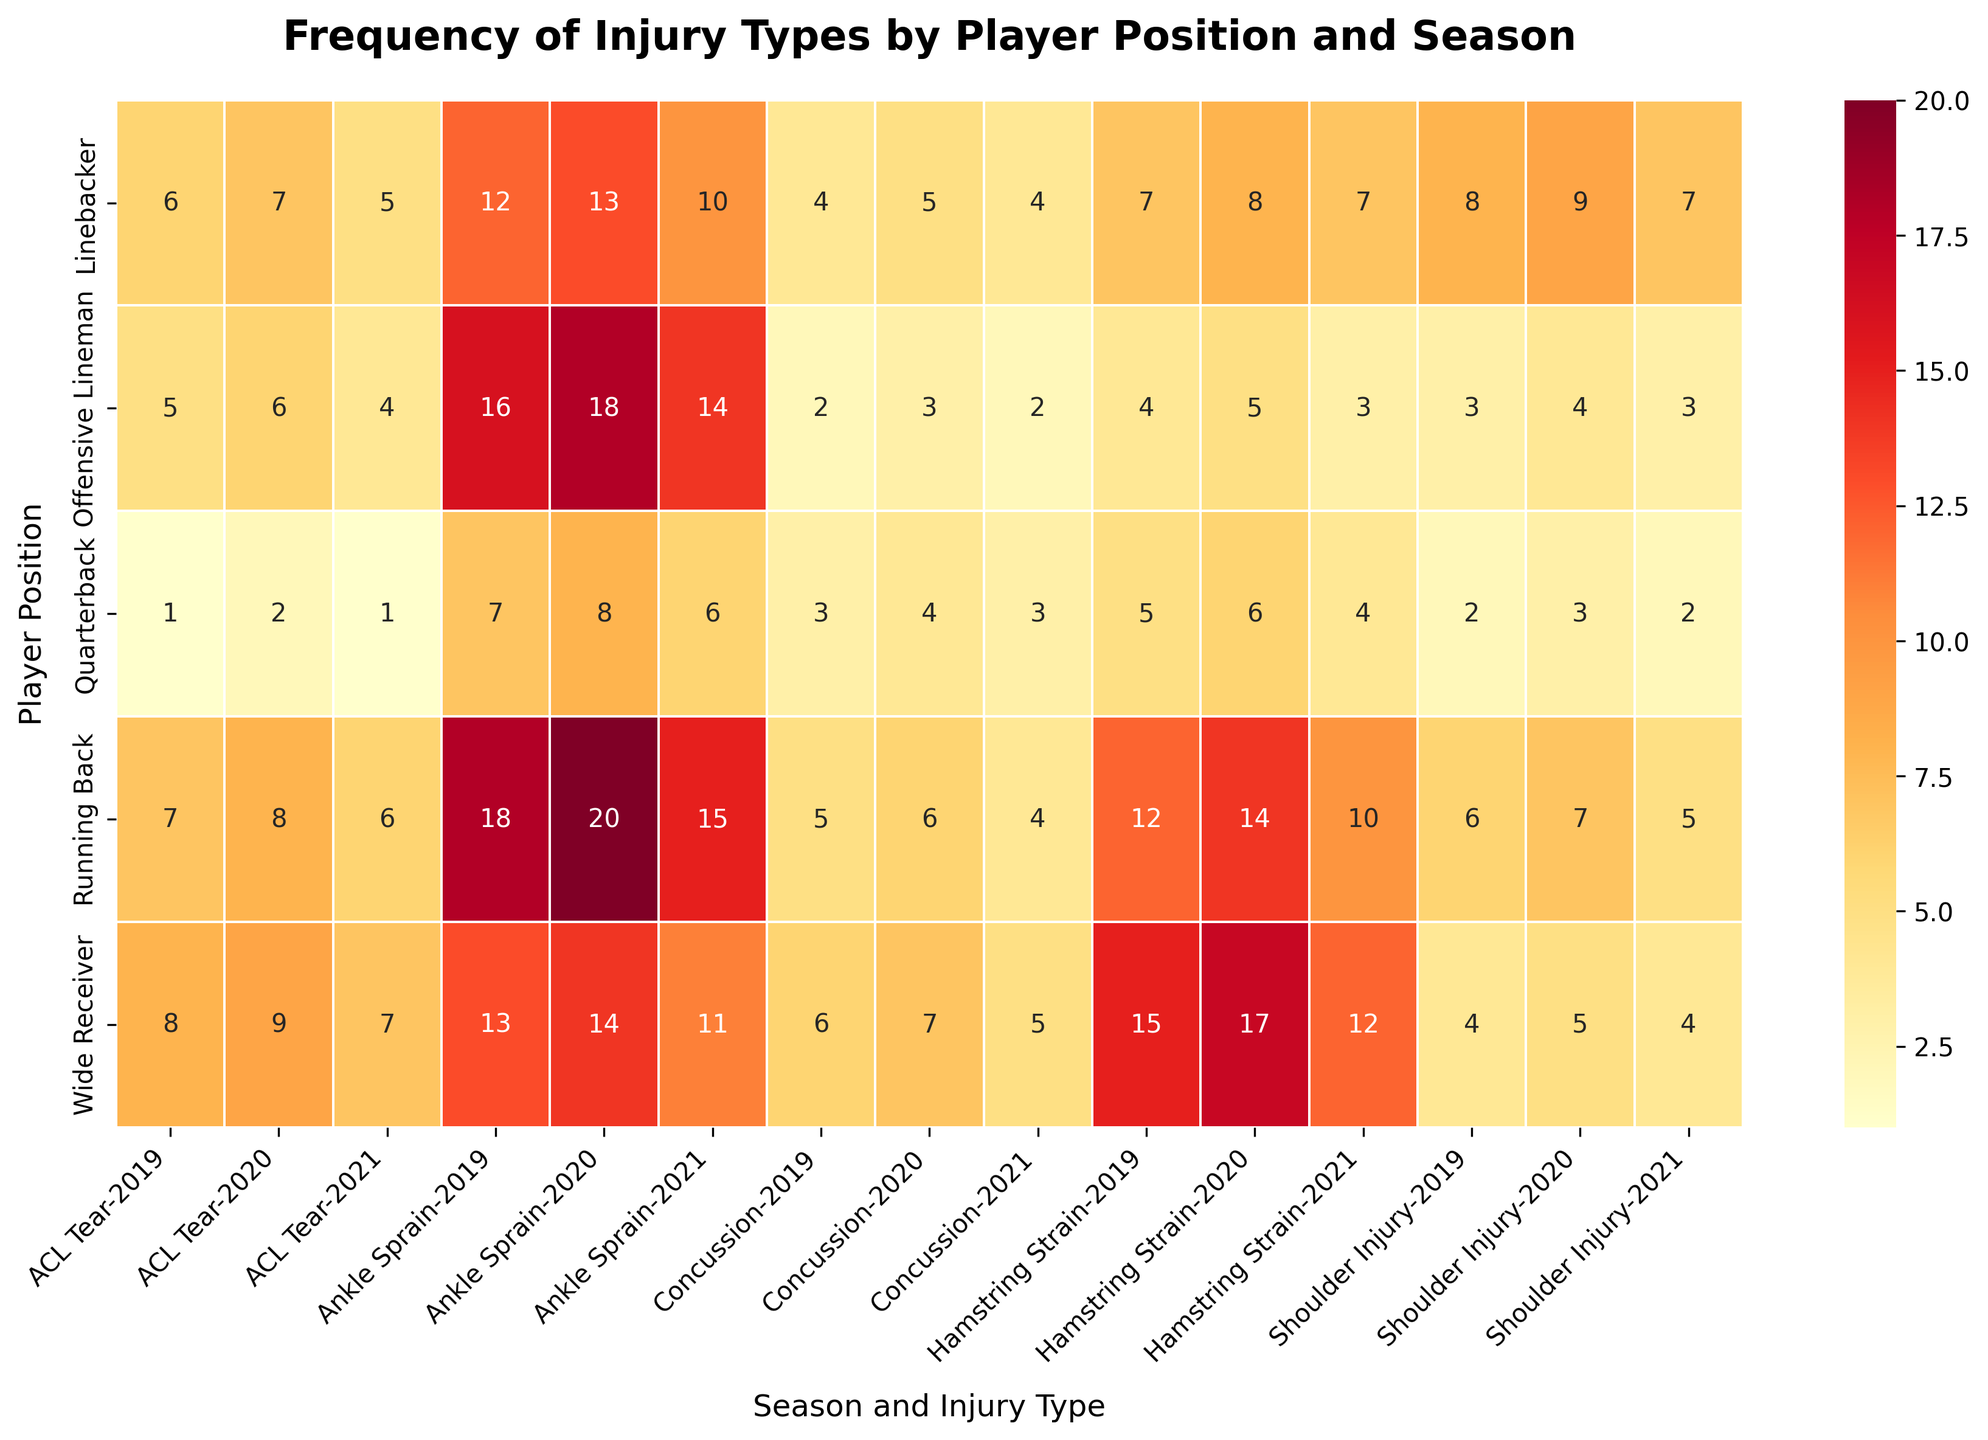Who had the highest number of Hamstring Strains in 2020? In the heatmap, look under the "Hamstring Strain" column for the year 2020 and compare the frequencies recorded for each player position. The position with the highest frequency will be your answer.
Answer: Wide Receiver Which season saw the most Concussions for Quarterbacks? Check the rows corresponding to Quarterbacks and compare the Concussion values across the seasons. Identify the season with the highest frequency.
Answer: 2020 What's the total number of Ankle Sprains for Running Backs across all three seasons? Identify the Ankle Sprain frequency for Running Backs for each season, then sum them up: 18 (2019) + 20 (2020) + 15 (2021).
Answer: 53 Which position experienced fewer Shoulder Injuries in 2021 than 2020? Look at the Shoulder Injury frequencies in the years 2020 and 2021 for each player position. Compare these frequencies to determine which position had a decrease.
Answer: Linebacker Did the number of ACL Tears among Offensive Linemen increase or decrease from 2019 to 2020? Review the ACL Tear frequencies for Offensive Linemen in 2019 and 2020 and compare them to see if there was an increase or decrease.
Answer: Increase Among Tight Ends and Kickers, who suffered more injuries overall in 2019? The figure does not include data for Tight Ends or Kickers. Therefore, comparisons for these positions cannot be made.
Answer: Data not available Which injury type shows the highest frequency difference between Wide Receivers and Quarterbacks in 2021? For the year 2021, calculate the difference between the frequencies for Wide Receivers and Quarterbacks for each injury type. Identify the injury type with the largest numerical difference.
Answer: Hamstring Strain How many total injuries did Linebackers sustain in 2020? Add up all types of injuries experienced by Linebackers in the year 2020.
Answer: 42 What is the average number of Shoulder Injuries across all positions in 2019? Sum the Shoulder Injury frequencies for all positions in 2019: (2+4+6+8+3) = 23. Then, divide this sum by the number of positions, which is 5.
Answer: 4.6 Compare the frequency of ACL Tears between Running Backs and Offensive Linemen in 2021. Which position had more? Look at the ACL Tear frequencies for both Running Backs and Offensive Linemen in the year 2021 and determine which is greater.
Answer: Running Back 